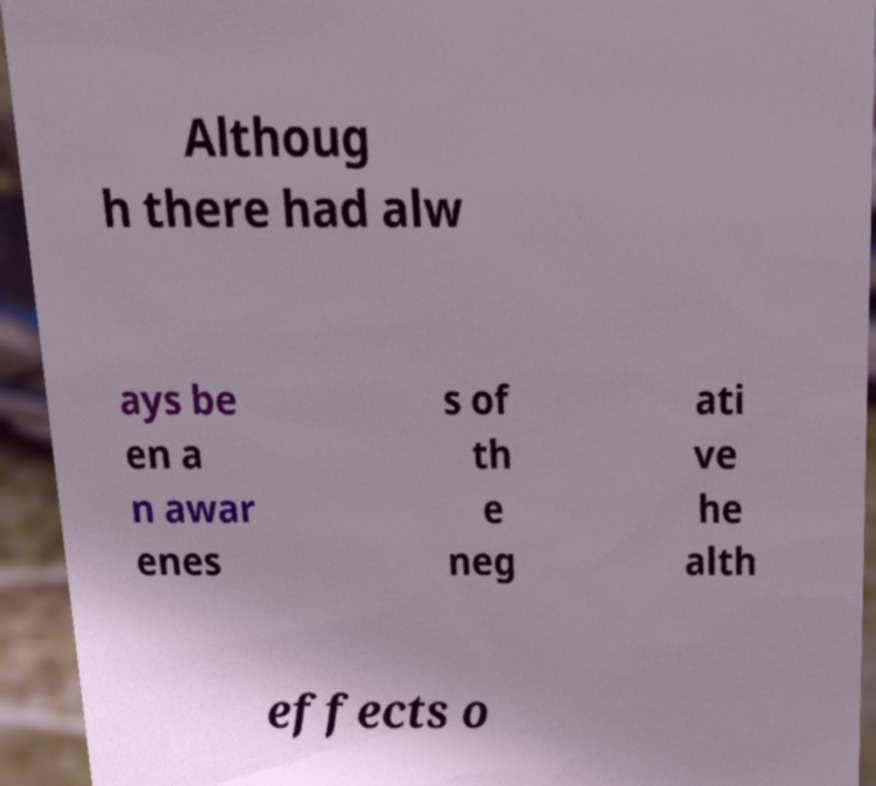I need the written content from this picture converted into text. Can you do that? Althoug h there had alw ays be en a n awar enes s of th e neg ati ve he alth effects o 